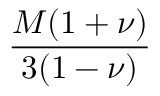<formula> <loc_0><loc_0><loc_500><loc_500>\frac { M ( 1 + \nu ) } { 3 ( 1 - \nu ) }</formula> 